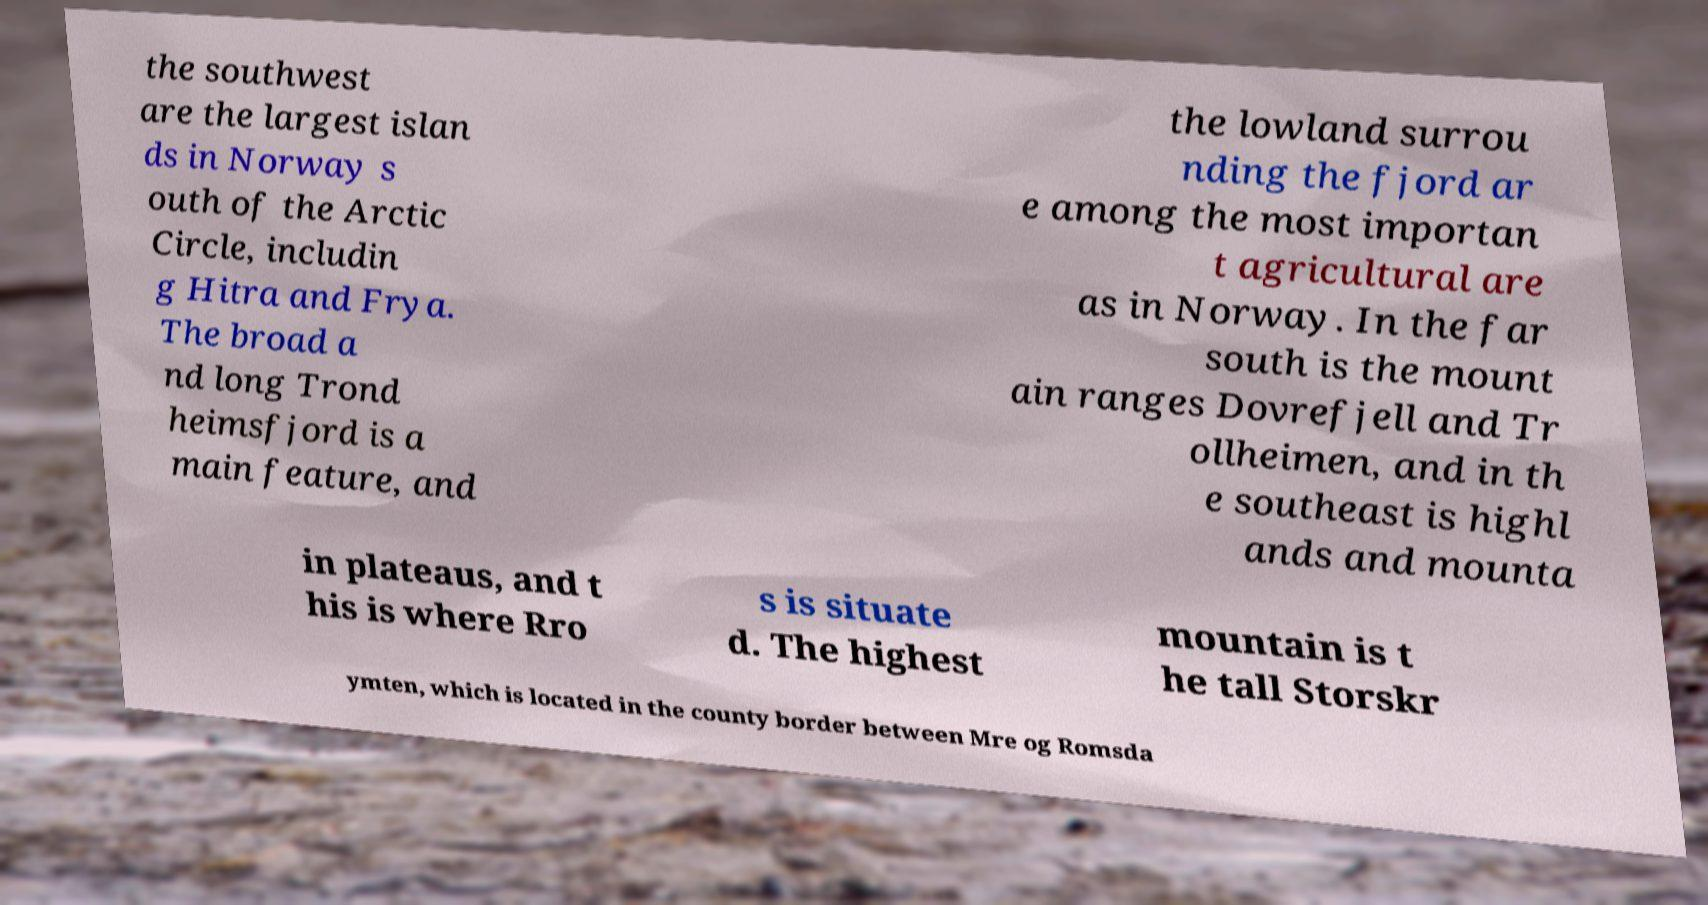Please identify and transcribe the text found in this image. the southwest are the largest islan ds in Norway s outh of the Arctic Circle, includin g Hitra and Frya. The broad a nd long Trond heimsfjord is a main feature, and the lowland surrou nding the fjord ar e among the most importan t agricultural are as in Norway. In the far south is the mount ain ranges Dovrefjell and Tr ollheimen, and in th e southeast is highl ands and mounta in plateaus, and t his is where Rro s is situate d. The highest mountain is t he tall Storskr ymten, which is located in the county border between Mre og Romsda 